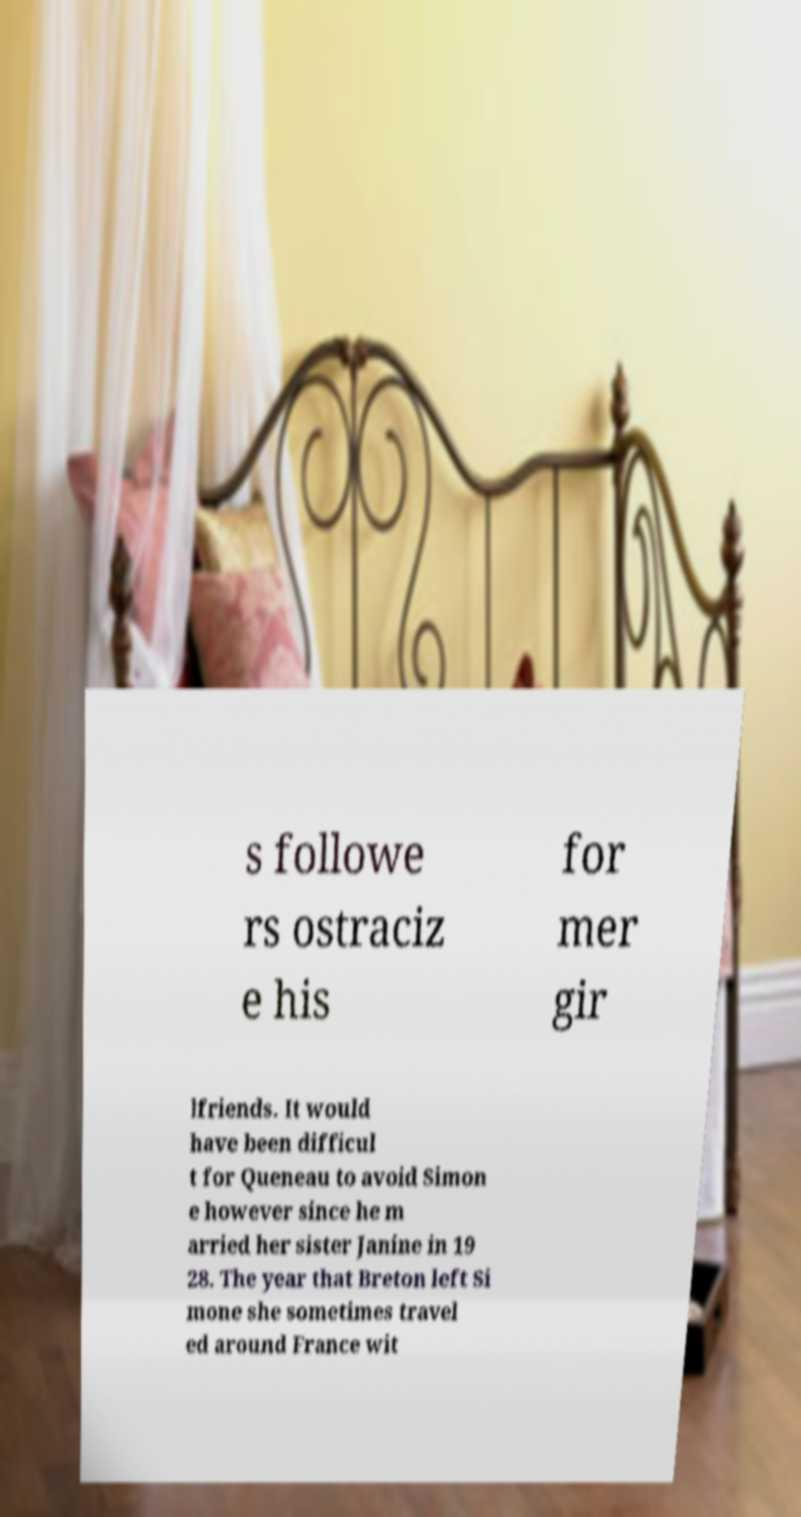Can you accurately transcribe the text from the provided image for me? s followe rs ostraciz e his for mer gir lfriends. It would have been difficul t for Queneau to avoid Simon e however since he m arried her sister Janine in 19 28. The year that Breton left Si mone she sometimes travel ed around France wit 